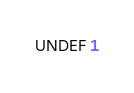<code> <loc_0><loc_0><loc_500><loc_500><_SQL_>UNDEF 1
</code> 